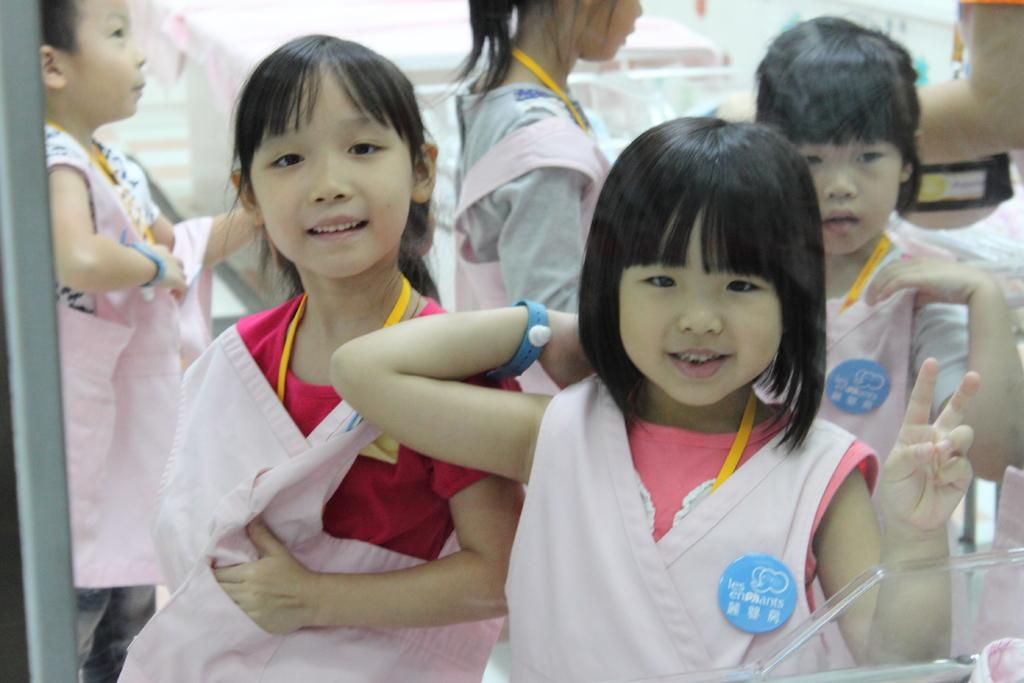Who is present in the image? There are kids in the image. What are the kids wearing? The kids are wearing pink clothes. What can be seen in the bottom right of the image? There is a glass material in the bottom right of the image. What is visible in the background of the image? There is a table in the background of the image. How is the table decorated or covered? The table is covered with a cloth. Can you see any flowers growing near the river in the image? There is no river or flowers present in the image; it features kids wearing pink clothes and a table with a cloth covering. 